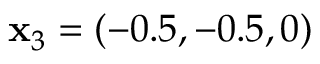Convert formula to latex. <formula><loc_0><loc_0><loc_500><loc_500>x _ { 3 } = ( - 0 . 5 , - 0 . 5 , 0 )</formula> 